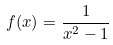<formula> <loc_0><loc_0><loc_500><loc_500>f ( x ) = \frac { 1 } { x ^ { 2 } - 1 }</formula> 